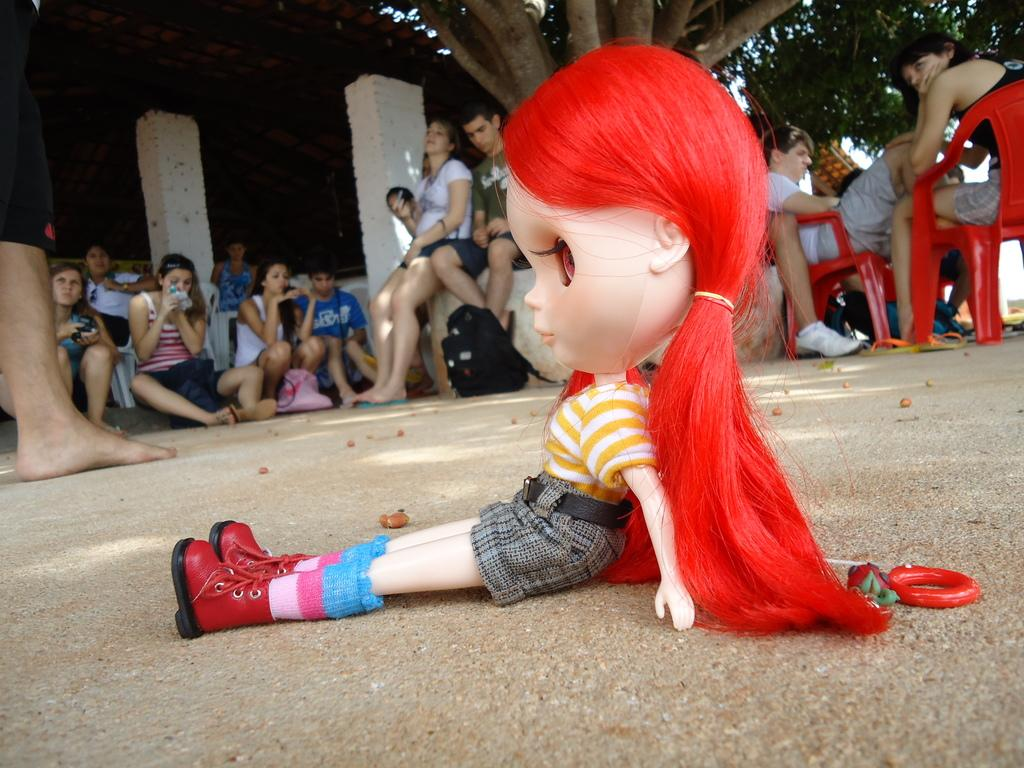What is the main subject in the front of the image? There is a doll in the front of the image. What can be seen in the background of the image? There are persons sitting and trees in the background of the image. Are there any architectural features visible in the background? Yes, there are pillars in the background of the image. What type of coach is present in the image? There is no coach present in the image. What type of work are the persons in the background doing? The provided facts do not mention any specific work being done by the persons in the background. 